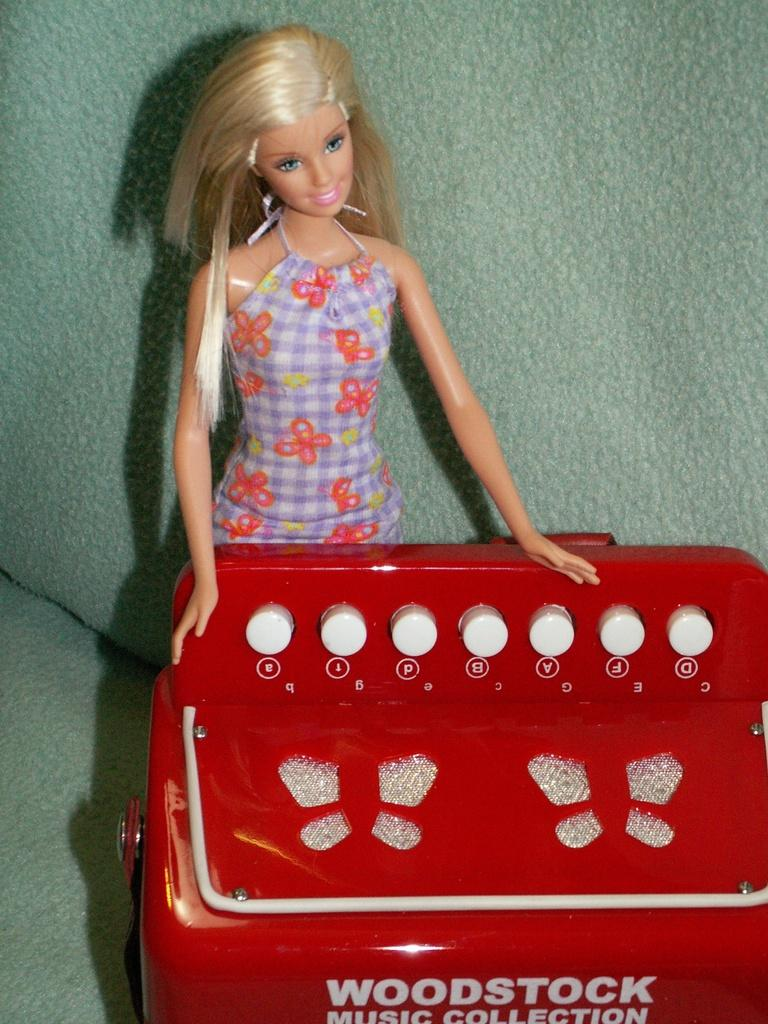What object can be seen in the image? There is a toy in the image. What feature is present on the toy? There is text on the toy. How many rabbits are jumping through the stamp in the image? There are no rabbits or stamps present in the image. 